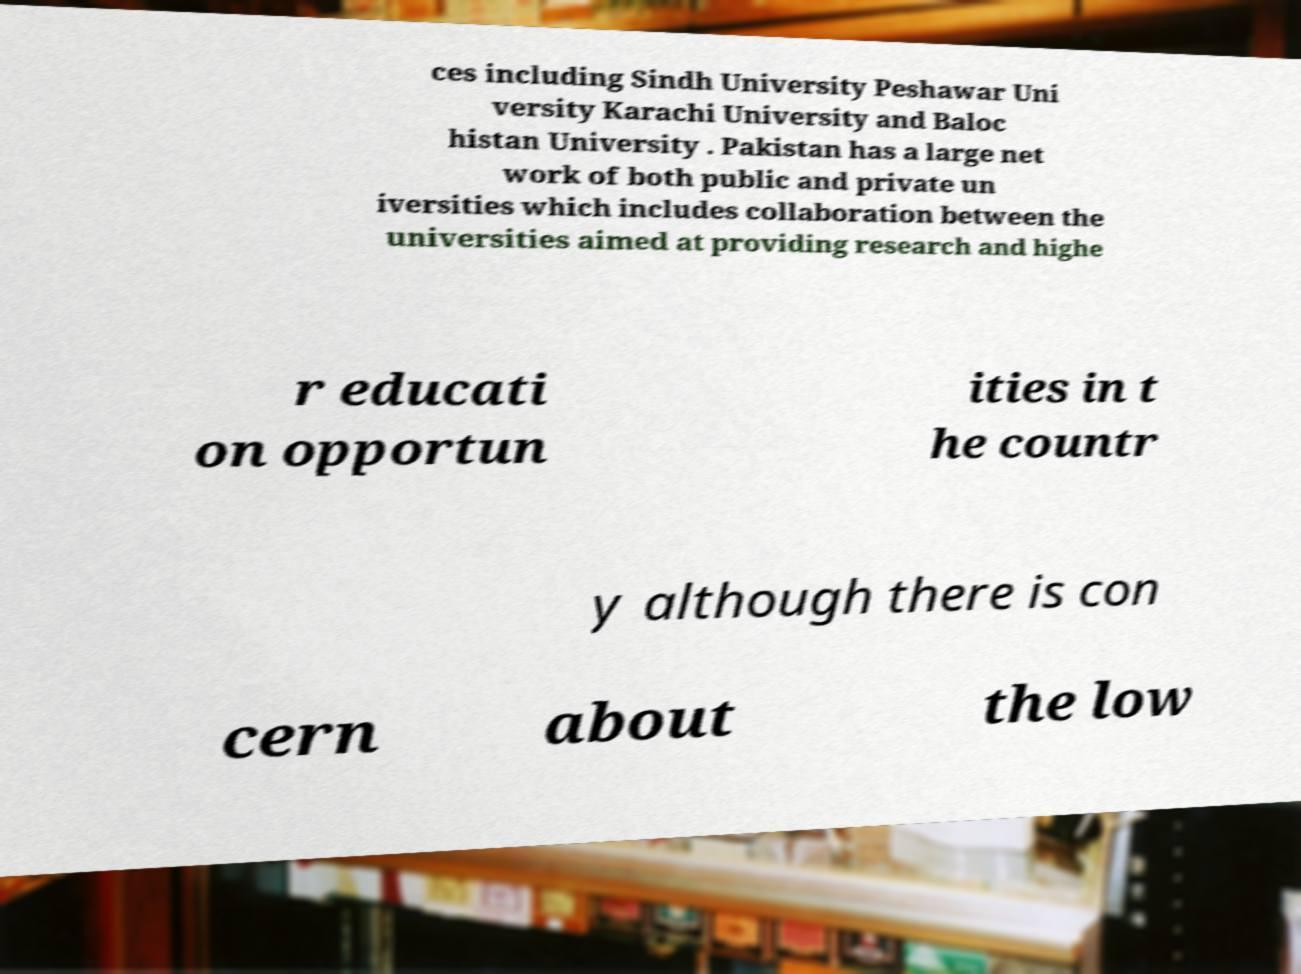I need the written content from this picture converted into text. Can you do that? ces including Sindh University Peshawar Uni versity Karachi University and Baloc histan University . Pakistan has a large net work of both public and private un iversities which includes collaboration between the universities aimed at providing research and highe r educati on opportun ities in t he countr y although there is con cern about the low 